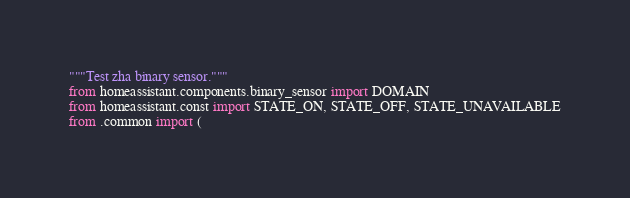<code> <loc_0><loc_0><loc_500><loc_500><_Python_>"""Test zha binary sensor."""
from homeassistant.components.binary_sensor import DOMAIN
from homeassistant.const import STATE_ON, STATE_OFF, STATE_UNAVAILABLE
from .common import (</code> 